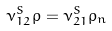Convert formula to latex. <formula><loc_0><loc_0><loc_500><loc_500>\nu ^ { S } _ { 1 2 } \rho = \nu ^ { S } _ { 2 1 } \rho _ { n }</formula> 